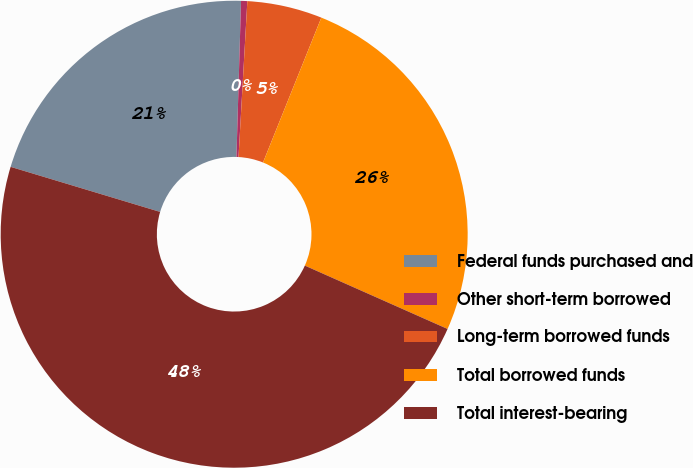Convert chart to OTSL. <chart><loc_0><loc_0><loc_500><loc_500><pie_chart><fcel>Federal funds purchased and<fcel>Other short-term borrowed<fcel>Long-term borrowed funds<fcel>Total borrowed funds<fcel>Total interest-bearing<nl><fcel>20.81%<fcel>0.43%<fcel>5.19%<fcel>25.56%<fcel>48.01%<nl></chart> 